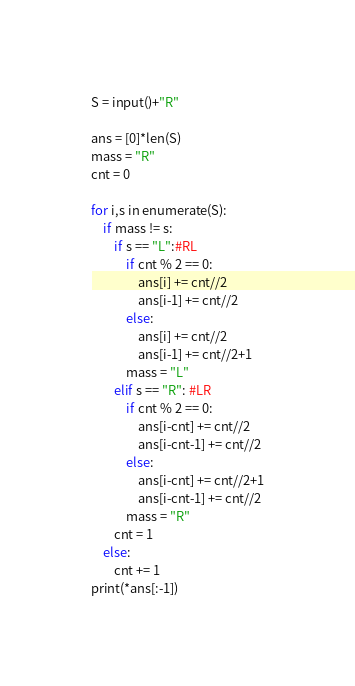Convert code to text. <code><loc_0><loc_0><loc_500><loc_500><_Python_>S = input()+"R"

ans = [0]*len(S)
mass = "R"
cnt = 0

for i,s in enumerate(S):
	if mass != s:
		if s == "L":#RL
			if cnt % 2 == 0:
				ans[i] += cnt//2
				ans[i-1] += cnt//2
			else:
				ans[i] += cnt//2
				ans[i-1] += cnt//2+1
			mass = "L"
		elif s == "R": #LR
			if cnt % 2 == 0:
				ans[i-cnt] += cnt//2
				ans[i-cnt-1] += cnt//2
			else:
				ans[i-cnt] += cnt//2+1
				ans[i-cnt-1] += cnt//2
			mass = "R"
		cnt = 1
	else:
		cnt += 1
print(*ans[:-1])</code> 